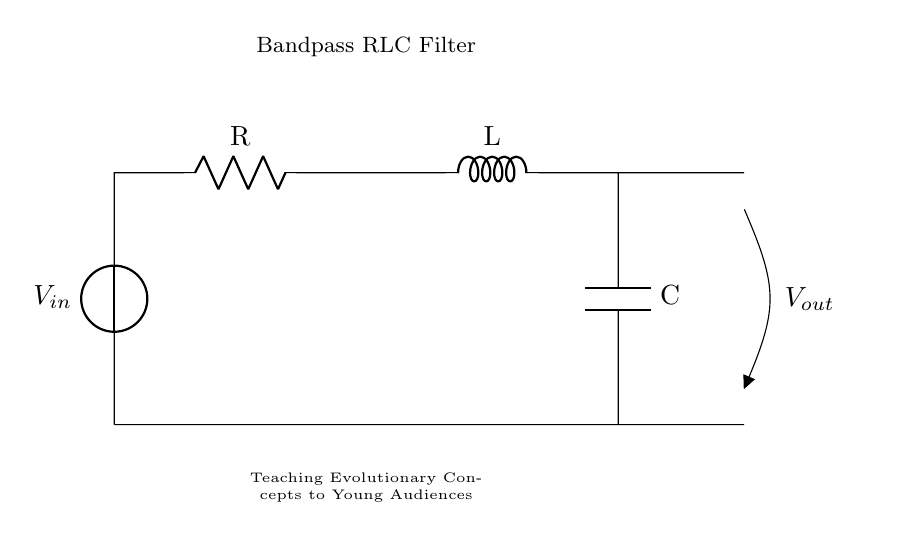What components are in the circuit? The circuit contains a voltage source, a resistor, an inductor, and a capacitor. Each component is essential for forming the bandpass filter.
Answer: voltage source, resistor, inductor, capacitor What is the output voltage labeled as? The output voltage is indicated by the symbol V-out, which is seen on the right side of the circuit.
Answer: V-out What is the purpose of this RLC circuit? The circuit serves as a bandpass filter, designed to allow certain frequencies to pass while blocking others, which is beneficial for multimedia presentations.
Answer: bandpass filter Which component is connected to the voltage source? The resistor is the first component connected to the voltage source; it takes in the voltage from the source.
Answer: resistor How does the inductor affect the circuit? The inductor primarily influences the frequency response of the filter by resisting changes in current and can introduce phase shifts, shaping the output waveform.
Answer: affects frequency response What type of filter is this circuit classified as? This circuit is classified as a bandpass filter due to its ability to pass a specific range of frequencies while attenuating others.
Answer: bandpass filter How would you describe the configuration of the components in the circuit? The components are arranged in a series configuration, where the resistor, inductor, and capacitor are connected in a loop between the input and output.
Answer: series configuration 